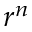Convert formula to latex. <formula><loc_0><loc_0><loc_500><loc_500>r ^ { n }</formula> 